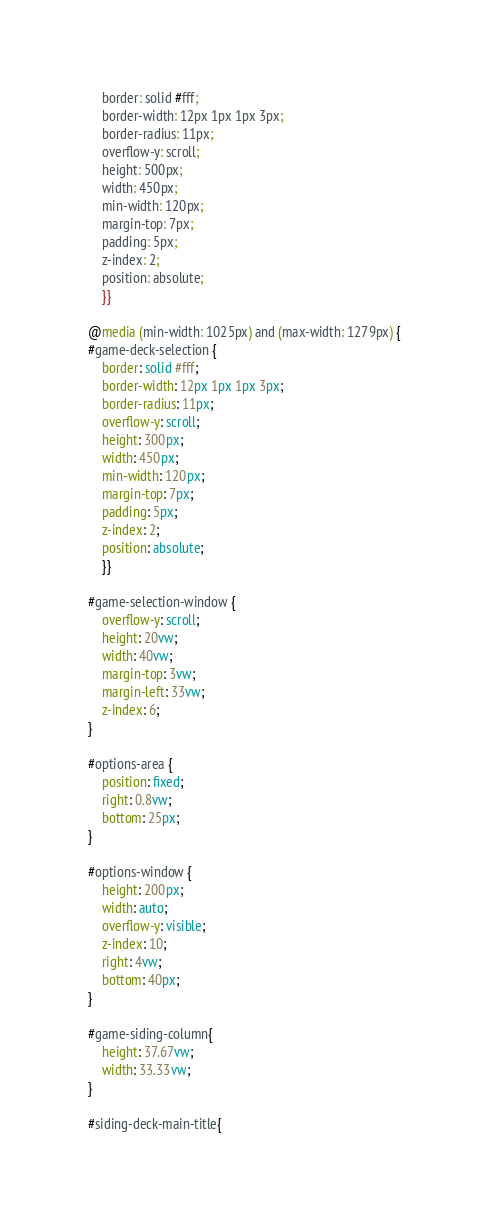Convert code to text. <code><loc_0><loc_0><loc_500><loc_500><_CSS_>	border: solid #fff;
	border-width: 12px 1px 1px 3px;
	border-radius: 11px;
	overflow-y: scroll;
	height: 500px;
	width: 450px;
	min-width: 120px;
	margin-top: 7px;
	padding: 5px;
	z-index: 2;
	position: absolute;
	}}

@media (min-width: 1025px) and (max-width: 1279px) {
#game-deck-selection {
	border: solid #fff;
	border-width: 12px 1px 1px 3px;
	border-radius: 11px;
	overflow-y: scroll;
	height: 300px;
	width: 450px;
	min-width: 120px;
	margin-top: 7px;
	padding: 5px;
	z-index: 2;
	position: absolute;
	}}

#game-selection-window {
	overflow-y: scroll;
	height: 20vw;
	width: 40vw;
	margin-top: 3vw;
	margin-left: 33vw;
	z-index: 6;
}

#options-area {
	position: fixed;
	right: 0.8vw;
	bottom: 25px;
}

#options-window {
	height: 200px;
	width: auto;
	overflow-y: visible;
	z-index: 10;
	right: 4vw;
	bottom: 40px;
}

#game-siding-column{
	height: 37.67vw;
	width: 33.33vw;
}

#siding-deck-main-title{</code> 